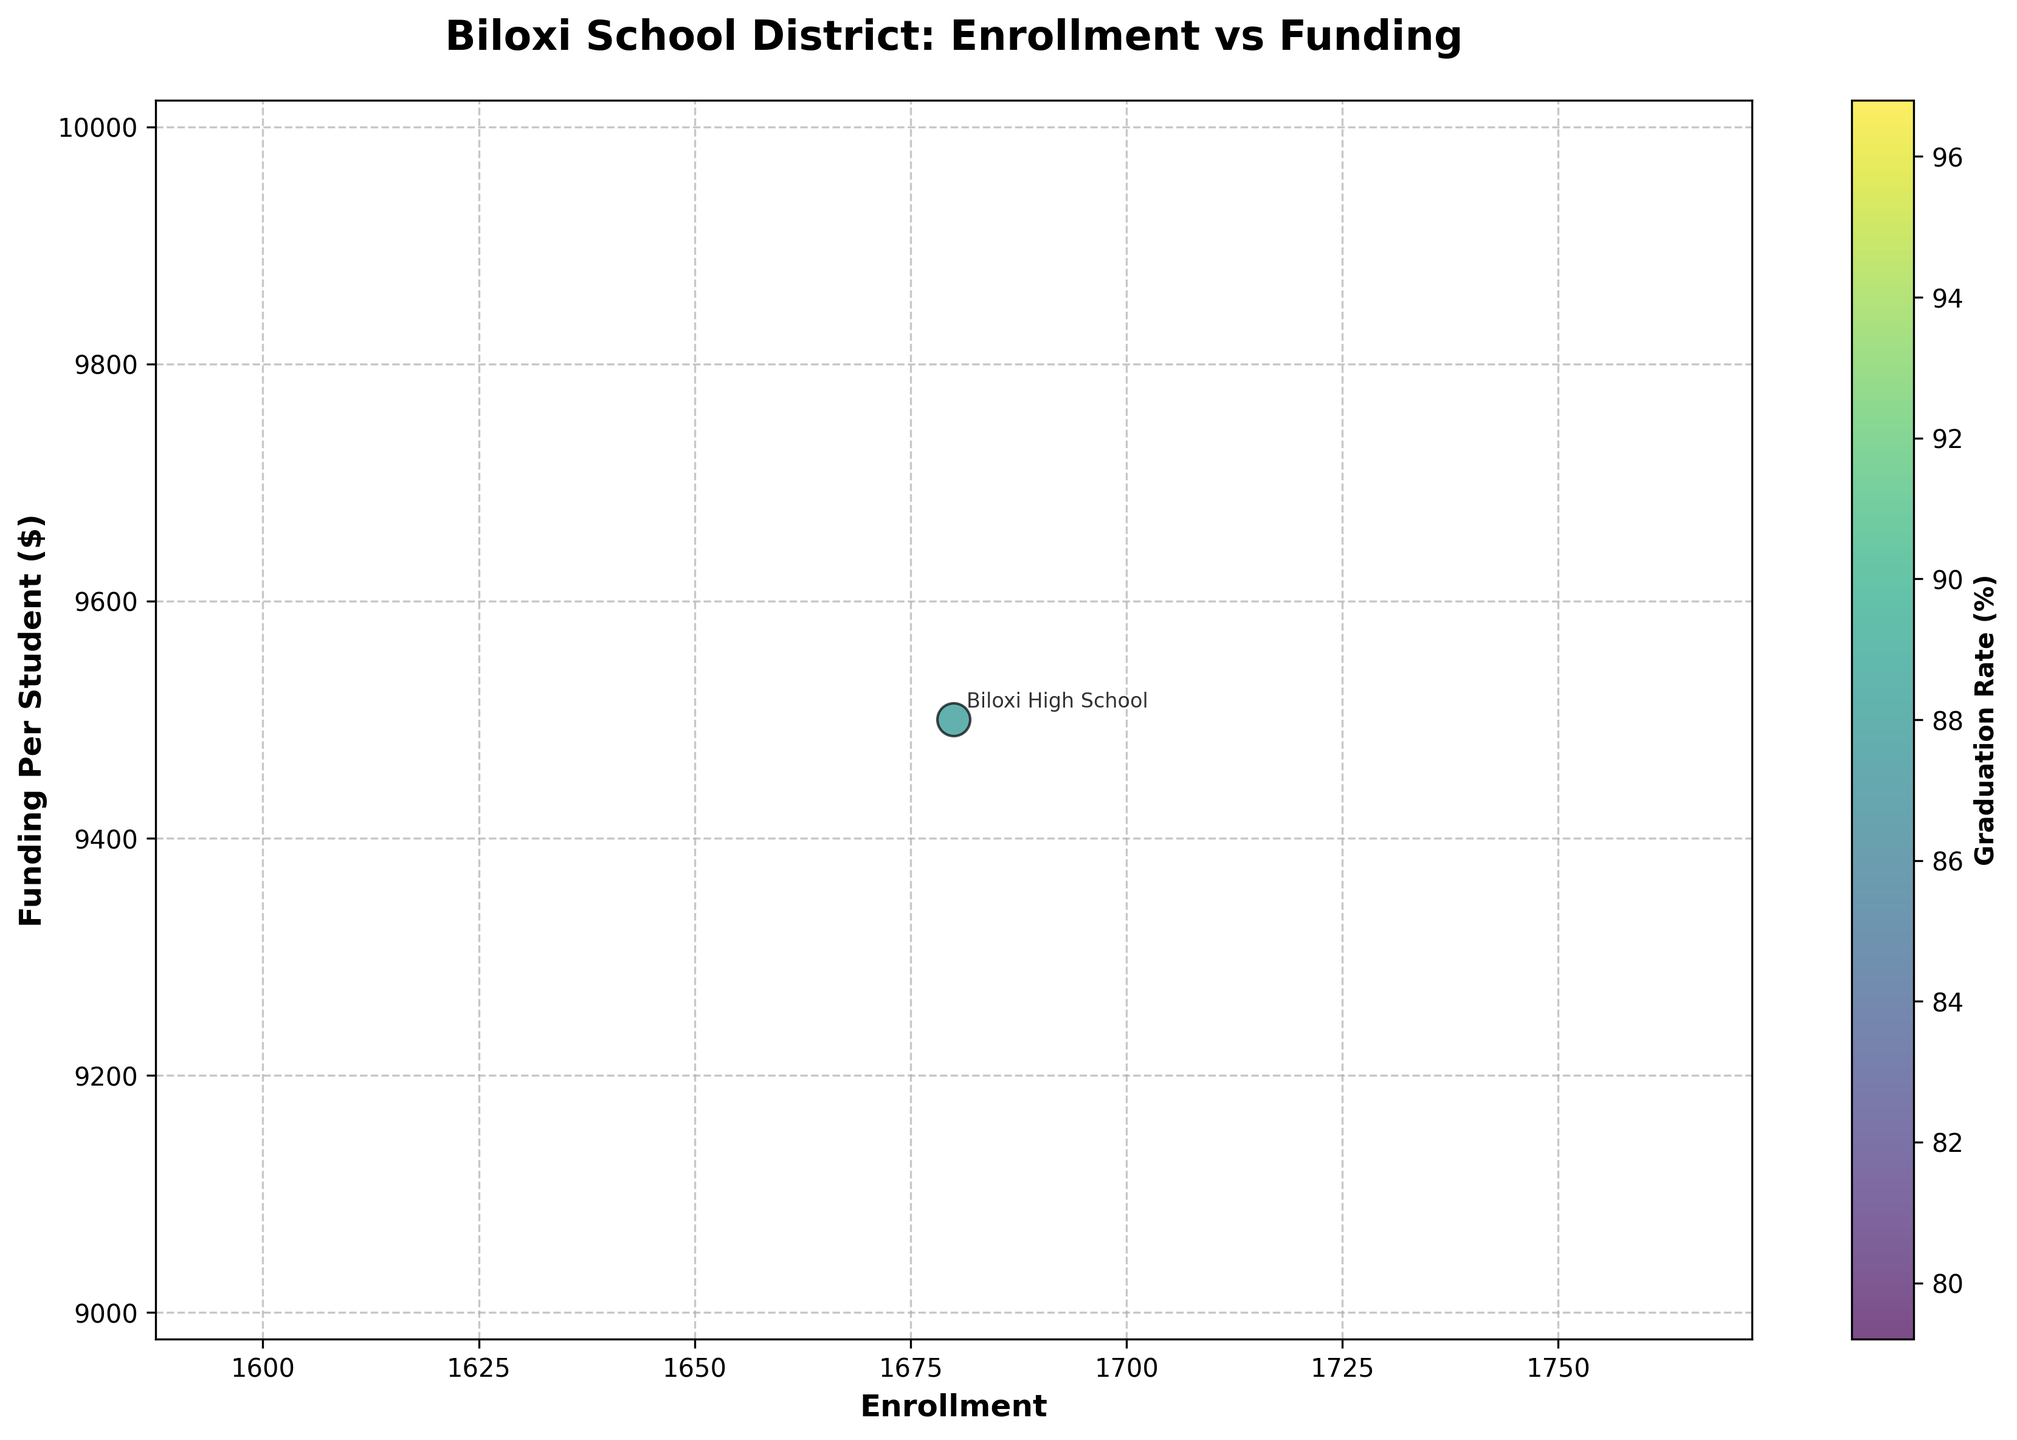How many schools are included in the figure? The figure has one bubble for each school. By counting the number of bubbles, we can see there are 10 schools in the Biloxi school district included in the figure.
Answer: 10 Which school has the highest enrollment? By looking at the bubble sizes, which are proportional to enrollment, the largest bubble represents Biloxi High School.
Answer: Biloxi High School What is the title of the figure? The title is displayed at the top of the figure. It reads "Biloxi School District: Enrollment vs Funding".
Answer: Biloxi School District: Enrollment vs Funding Which school has the highest funding per student? By checking the vertical axis (Funding) and seeing the highest position, we observe that Biloxi High School is the one with the highest funding per student.
Answer: Biloxi High School Which school has the lowest graduation rate, and what is that rate? Look at the color of the bubbles, which represents graduation rates with the help of the color bar. Biloxi High School is the only one with a graduation rate, and it is 88%. Therefore, Biloxi High School, 88%.
Answer: Biloxi High School, 88% How does the funding of North Bay Elementary compare to that of Nichols Elementary? Looking at the vertical positions of both bubbles, North Bay Elementary is positioned at $8200 while Nichols Elementary is at $8000.
Answer: North Bay Elementary has higher funding than Nichols Elementary What is the range of enrollment among the schools? Find the highest and lowest points on the horizontal axis (Enrollment). The highest is Biloxi High School at 1680 students, and the lowest is Lopez School at 230 students. The range is 1680 - 230.
Answer: 1450 How many schools do not have a graduation rate listed in the figure? By examining the color of the bubbles and comparing it to the color bar, all bubbles except for Biloxi High School do not have a corresponding color, indicating no graduation rate data. Hence, 9 schools have no graduation rate listed.
Answer: 9 If you sum the funding per student for Biloxi Junior High School and Lopez School, what do you get? Biloxi Junior High School has $8900 and Lopez School has $8400 funding per student. Summing them gives $8900 + $8400.
Answer: $17300 Which elementary school has the highest enrollment? By looking at the sizes and labels of the bubbles for elementary schools, Popp's Ferry Elementary has the largest bubble among the elementary schools, indicating the highest enrollment.
Answer: Popp's Ferry Elementary 